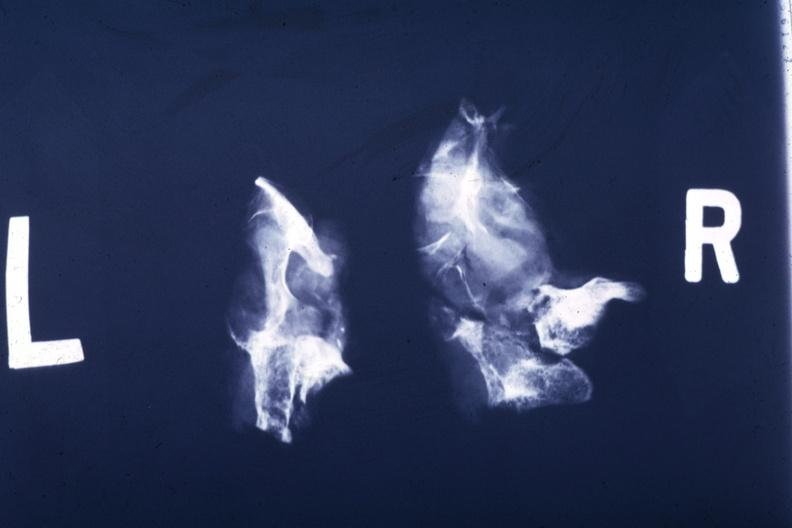where does this x-ray been taken?
Answer the question using a single word or phrase. Endocrine system 